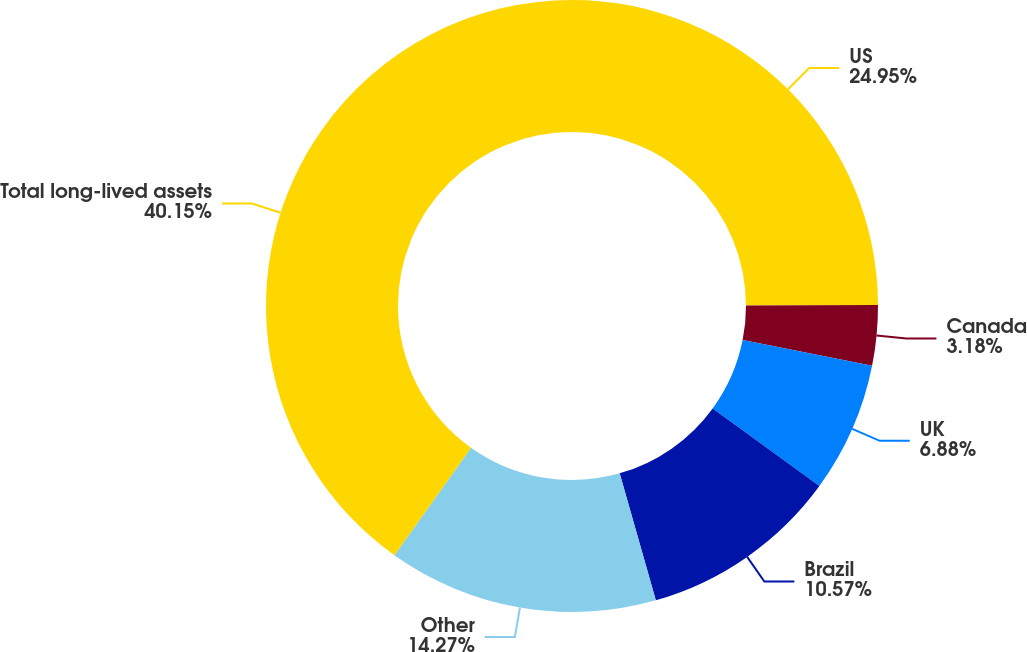<chart> <loc_0><loc_0><loc_500><loc_500><pie_chart><fcel>US<fcel>Canada<fcel>UK<fcel>Brazil<fcel>Other<fcel>Total long-lived assets<nl><fcel>24.95%<fcel>3.18%<fcel>6.88%<fcel>10.57%<fcel>14.27%<fcel>40.14%<nl></chart> 